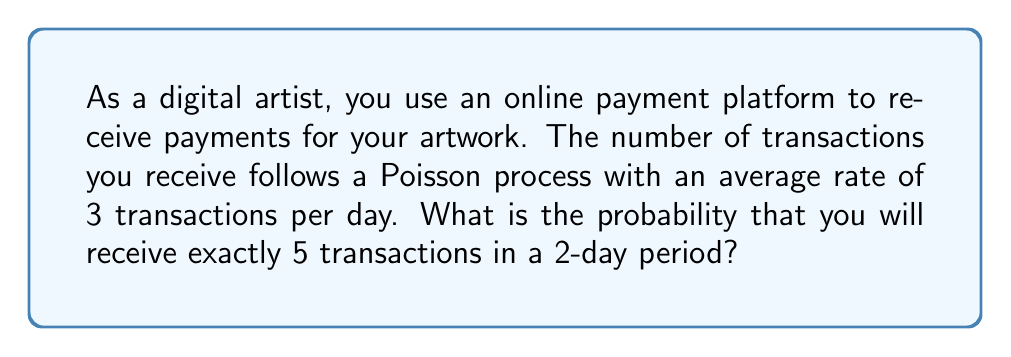Provide a solution to this math problem. Let's approach this step-by-step:

1) The Poisson process has a rate λ = 3 transactions per day.

2) We're looking at a 2-day period, so we need to adjust our rate:
   λ' = 3 * 2 = 6 transactions per 2-day period

3) We want to find P(X = 5), where X is the number of transactions in 2 days.

4) The Poisson probability mass function is:

   $$P(X = k) = \frac{e^{-λ} λ^k}{k!}$$

5) Plugging in our values:

   $$P(X = 5) = \frac{e^{-6} 6^5}{5!}$$

6) Let's calculate this:
   
   $$P(X = 5) = \frac{e^{-6} * 7776}{120}$$

7) Using a calculator:

   $$P(X = 5) ≈ 0.1606$$

Therefore, the probability of receiving exactly 5 transactions in a 2-day period is approximately 0.1606 or 16.06%.
Answer: 0.1606 